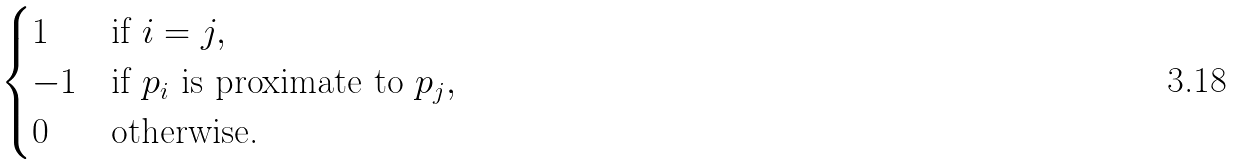<formula> <loc_0><loc_0><loc_500><loc_500>\begin{cases} 1 & \text {if } i = j , \\ - 1 & \text {if $p_{i}$ is proximate to $p_{j}$} , \\ 0 & \text {otherwise.} \end{cases}</formula> 